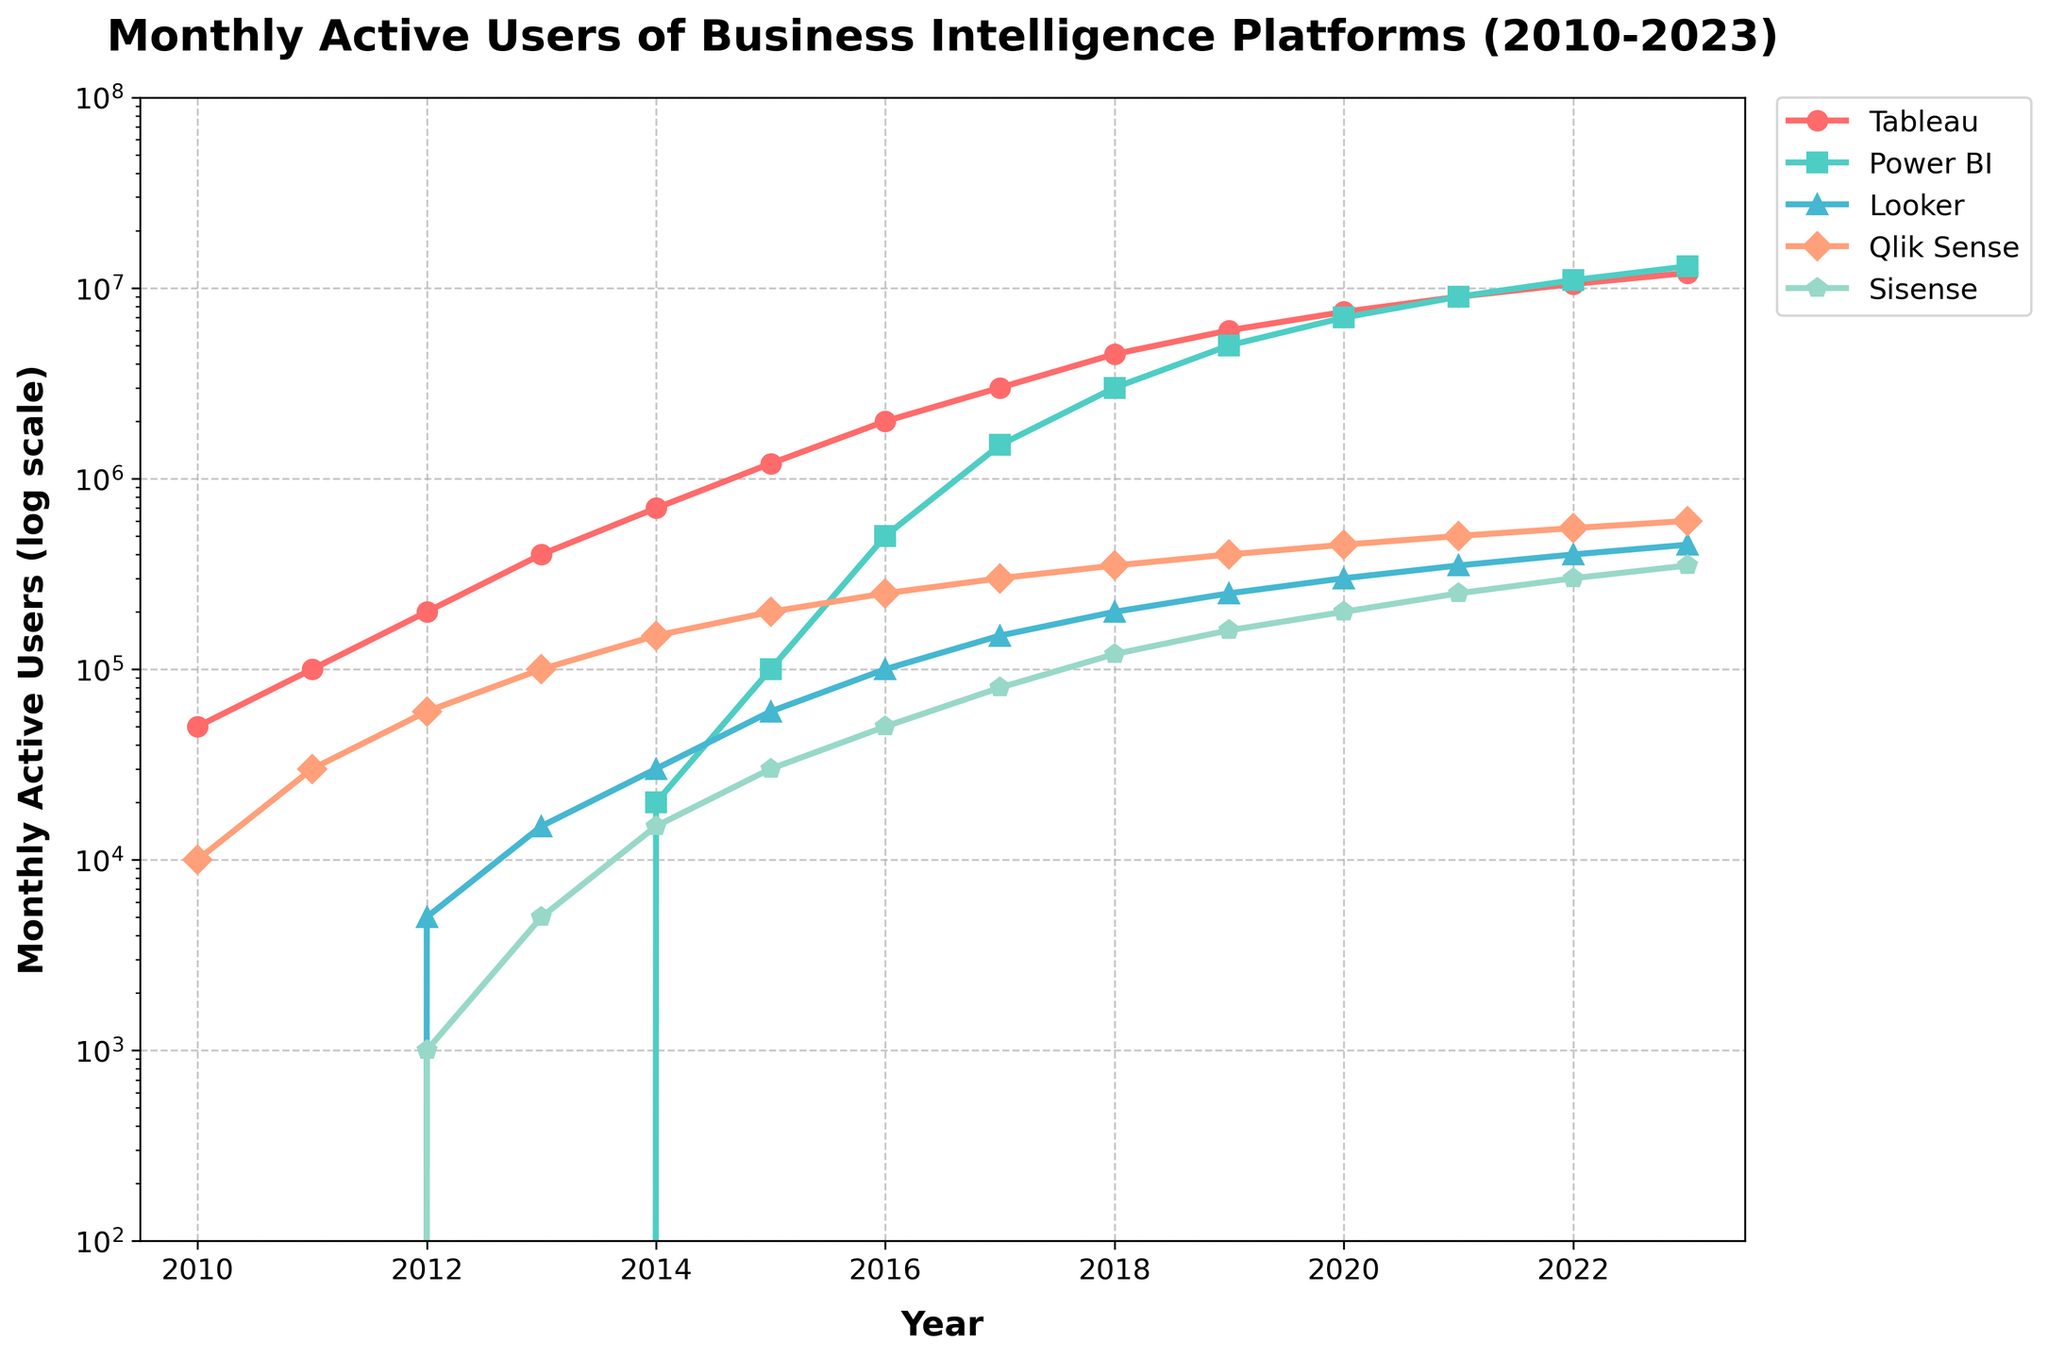What year did Power BI surpass Tableau in monthly active users? First, identify the point where Power BI's line crosses Tableau's line in the chart. This indicates the year Power BI surpassed Tableau in monthly active users. From the chart, this happens between 2021 and 2022.
Answer: 2022 Which platform had the second highest number of monthly active users in 2023 and how many users did it have? Identify the values for all platforms in 2023. Power BI had 13 million users, Tableau had 12 million, Looker had 450,000, Qlik Sense had 600,000, and Sisense had 350,000. The second highest value is 12 million for Tableau.
Answer: Tableau, 12 million What is the overall trend for Sisense from 2010 to 2023? Trace the line representing Sisense across the years. It starts at 0 in 2010 and gradually increases, reaching 350,000 by 2023. The overall trend is an upward increase.
Answer: Upward increase What is the combined number of active users for all platforms in 2015? Sum the values for all platforms in 2015: Tableau (1,200,000), Power BI (100,000), Looker (60,000), Qlik Sense (200,000), Sisense (30,000). 1,200,000 + 100,000 + 60,000 + 200,000 + 30,000 = 1,590,000.
Answer: 1,590,000 Which platform had the most significant growth in active users between 2020 and 2023? Calculate the difference in the number of active users from 2020 to 2023 for each platform: Tableau (12,000,000-7,500,000=4,500,000), Power BI (13,000,000-7,000,000=6,000,000), Looker (450,000-300,000=150,000), Qlik Sense (600,000-450,000=150,000), and Sisense (350,000-200,000=150,000). Power BI experienced the most significant growth.
Answer: Power BI Compare the growth rates of Looker and Sisense from 2010 to 2023. Looker started at 0 in 2010 and reached 450,000 in 2023, an increase of 450,000. Sisense started at 0 and reached 350,000 in 2023, an increase of 350,000. Looker had a higher growth rate compared to Sisense.
Answer: Looker had a higher growth rate What is the average number of monthly active users for Qlik Sense between 2010 and 2023? Add the values for Qlik Sense from 2010 to 2023 and divide by the number of years: (10,000+30,000+60,000+100,000+150,000+200,000+250,000+300,000+350,000+400,000+450,000+500,000+550,000+600,000)/14. The sum is 3,950,000, and the average is 3,950,000 / 14 ≈ 282,142.86.
Answer: ≈ 282,142.86 What visual attribute helps differentiate the lines of different platforms? The lines are differentiated by color, with each platform assigned a distinct color.
Answer: Color Which platform had the least number of active users in 2013, and how many did it have? Look at the values for all platforms in 2013. Tableau had 400,000, Power BI had 0, Looker had 15,000, Qlik Sense had 100,000, and Sisense had 5,000. Power BI had the least with 0, but excluding that, Sisense had the least with 5,000.
Answer: Sisense, 5,000 Estimate the rate of growth for Power BI from 2018 to 2023. Identify the number of active users for Power BI in 2018 (3,000,000) and in 2023 (13,000,000). The difference is 13,000,000 - 3,000,000 = 10,000,000 over 5 years. The estimated annual growth rate is 10,000,000 / 5 = 2,000,000 users per year.
Answer: 2,000,000 users/year 